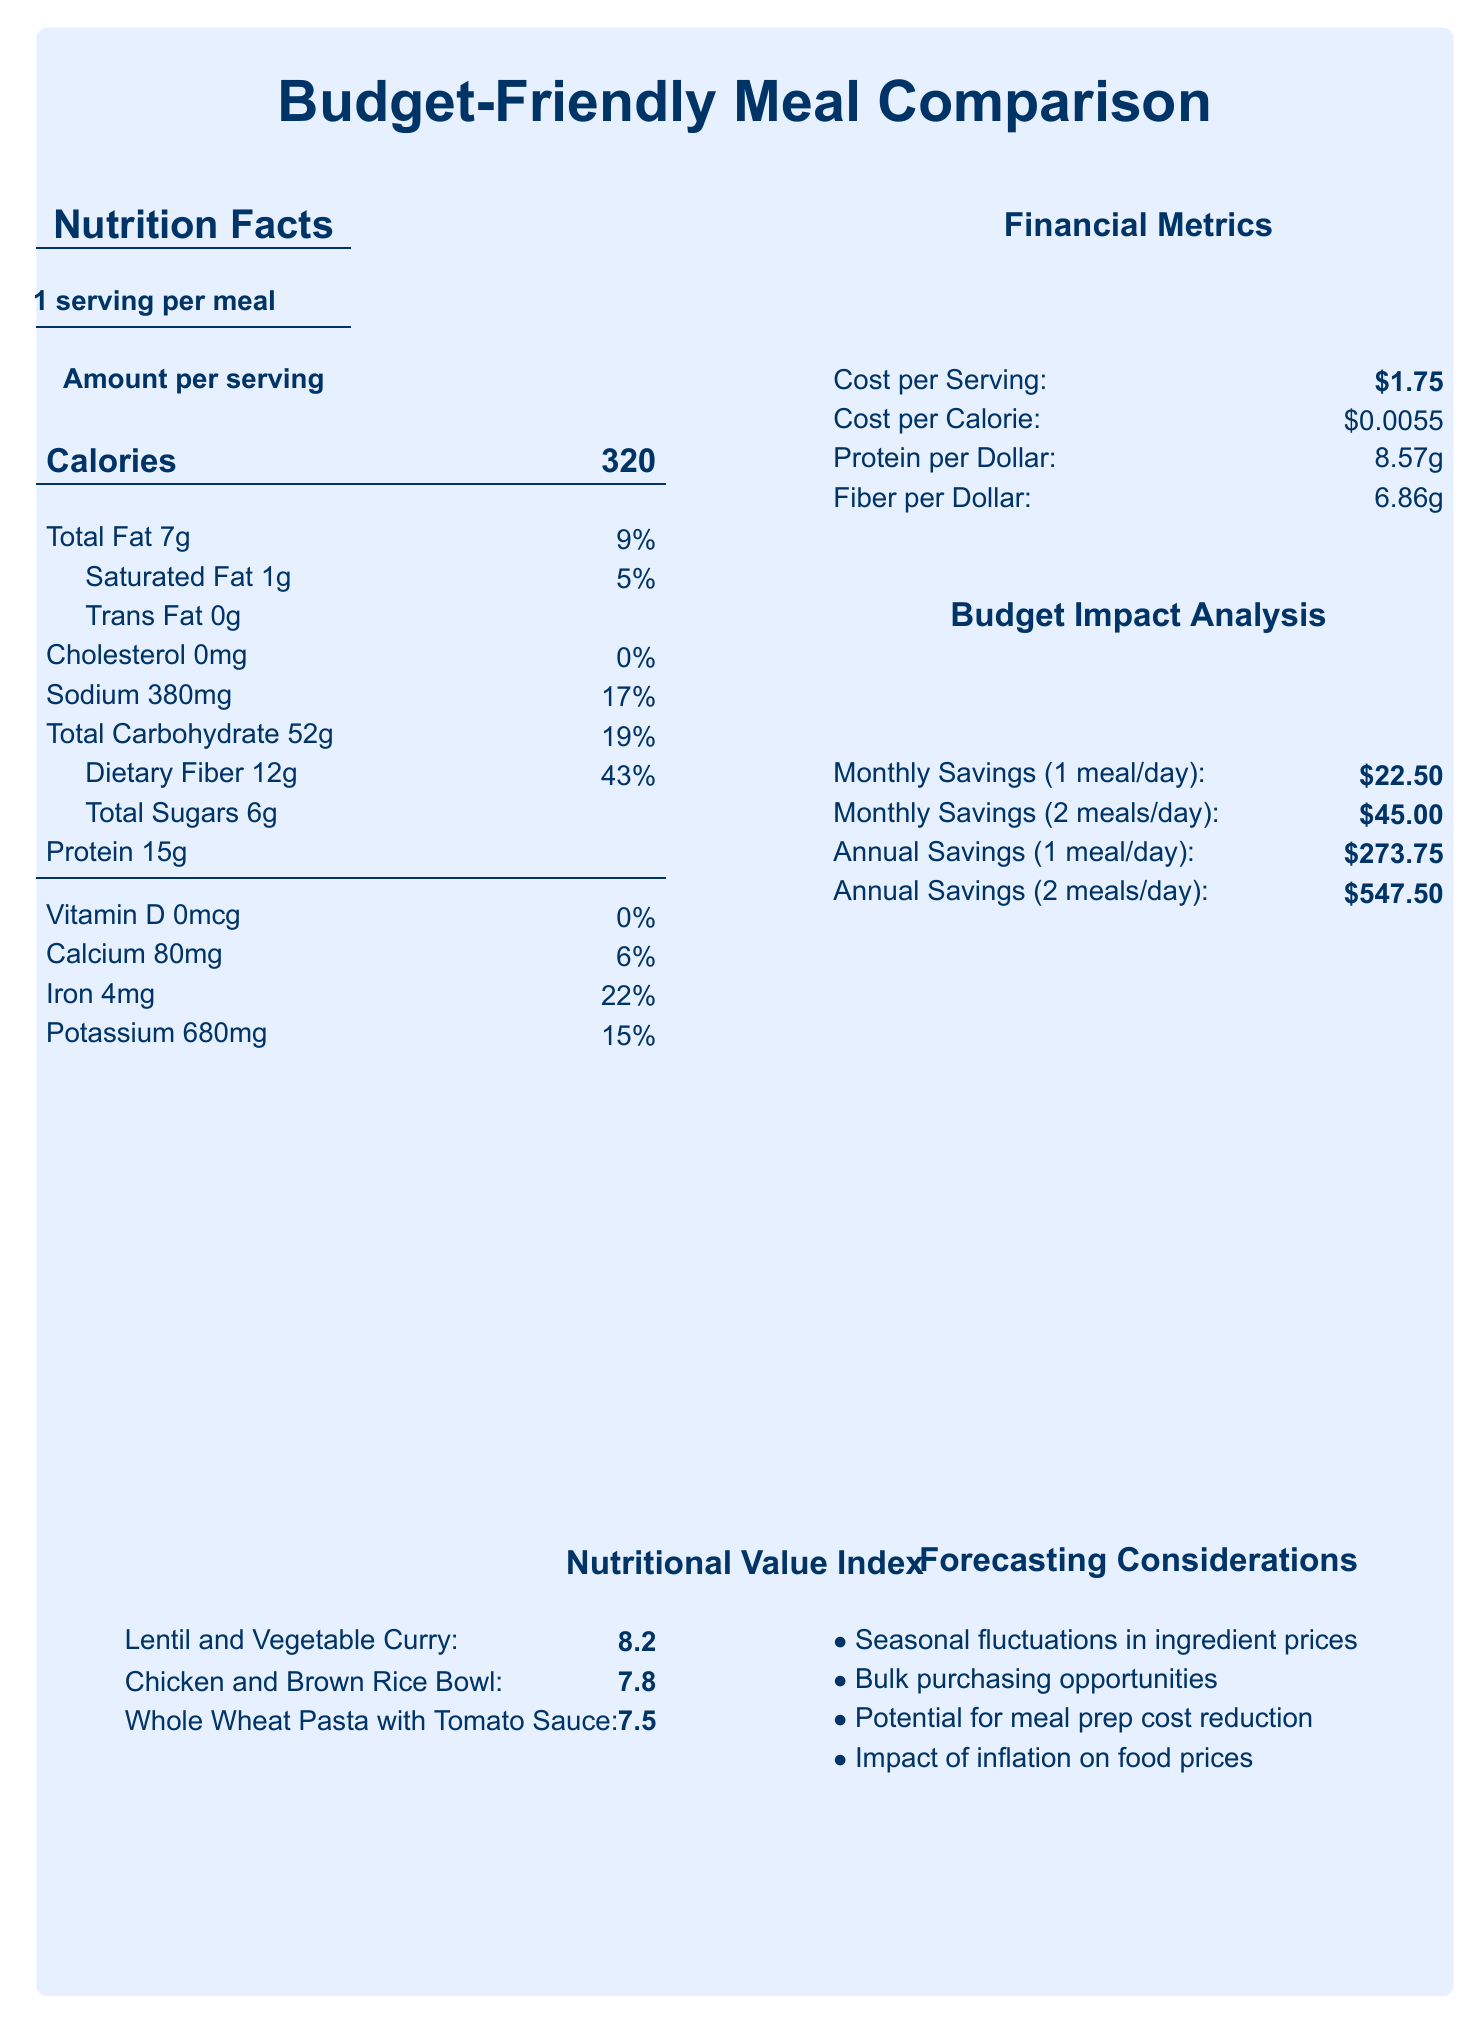What is the cost per serving of the Lentil and Vegetable Curry? The cost per serving for Lentil and Vegetable Curry is listed as $1.75 in the document.
Answer: $1.75 How many grams of total fat does the Chicken and Brown Rice Bowl contain? According to the document, the Chicken and Brown Rice Bowl contains 12 grams of total fat.
Answer: 12 grams What is the sodium content in the Whole Wheat Pasta with Tomato Sauce? The sodium content in Whole Wheat Pasta with Tomato Sauce is listed as 480 mg.
Answer: 480 mg How much protein per dollar does the Chicken and Brown Rice Bowl provide? The document states that the Chicken and Brown Rice Bowl provides 11.20 grams of protein per dollar.
Answer: 11.20 grams What is the nutritional value index of the Lentil and Vegetable Curry? The nutritional value index for Lentil and Vegetable Curry is 8.2, as listed in the document.
Answer: 8.2 Which meal option provides the highest dietary fiber per dollar? 
A. Lentil and Vegetable Curry 
B. Chicken and Brown Rice Bowl 
C. Whole Wheat Pasta with Tomato Sauce The document shows that Lentil and Vegetable Curry provides 6.86 grams of fiber per dollar, the highest among the three options.
Answer: A. Lentil and Vegetable Curry Which of the following meals has the lowest cost per calorie? 
1. Lentil and Vegetable Curry 
2. Chicken and Brown Rice Bowl 
3. Whole Wheat Pasta with Tomato Sauce The document indicates that Whole Wheat Pasta with Tomato Sauce has the lowest cost per calorie at $0.0033.
Answer: 3. Whole Wheat Pasta with Tomato Sauce Is there trans fat in any of the meal options? The document lists the trans fat content for all meals as 0 grams.
Answer: No Summarize the main idea of the document. The document is a comparative analysis of three meal options: Lentil and Vegetable Curry, Chicken and Brown Rice Bowl, and Whole Wheat Pasta with Tomato Sauce. It provides data on nutritional facts, financial metrics, budget impact scenarios, and forecasting considerations for cost-effective meal planning.
Answer: The document compares three budget-friendly meal options in terms of nutrition and financial metrics. It evaluates aspects such as cost per serving, nutritional content, and potential savings from meal substitutions, highlighting considerations for meal planning and forecasting. What is the annual savings for replacing all meals? The document states that the annual savings for replacing all meals is $821.25.
Answer: $821.25 Which meal option contains the most calories? The Chicken and Brown Rice Bowl contains 420 calories, the highest among the listed meals.
Answer: Chicken and Brown Rice Bowl How much Vitamin D is provided in the Lentil and Vegetable Curry? The document lists the Vitamin D content for Lentil and Vegetable Curry as 0 mcg.
Answer: 0 mcg What are the forecasting considerations mentioned in the document? The forecasting considerations include seasonal fluctuations in ingredient prices, bulk purchasing opportunities, potential for meal prep cost reduction, and the impact of inflation on food prices.
Answer: Seasonal fluctuations in ingredient prices, Bulk purchasing opportunities, Potential for meal prep cost reduction, Impact of inflation on food prices Which meal has the highest cholesterol content? The Chicken and Brown Rice Bowl has the highest cholesterol content at 65 mg.
Answer: Chicken and Brown Rice Bowl What is the total carbohydrate content of the Lentil and Vegetable Curry? The document lists the total carbohydrate content of the Lentil and Vegetable Curry as 52 grams.
Answer: 52 grams Does the document indicate any possible seasonal fluctuations in ingredients? One of the forecasting considerations mentioned is "Seasonal fluctuations in ingredient prices".
Answer: Yes Which meal option has the lowest amount of total sugars? The document shows that the Chicken and Brown Rice Bowl has a total sugar content of 2 grams, the lowest among the listed meal options.
Answer: Chicken and Brown Rice Bowl What is the calcium content in the Whole Wheat Pasta with Tomato Sauce? The document shows that the Whole Wheat Pasta with Tomato Sauce contains 60 mg of calcium.
Answer: 60 mg What would happen to the sodium content if the Lentil and Vegetable Curry recipe is doubled? The document does not provide information on how the sodium content would change if the recipe quantities are altered.
Answer: Cannot be determined 